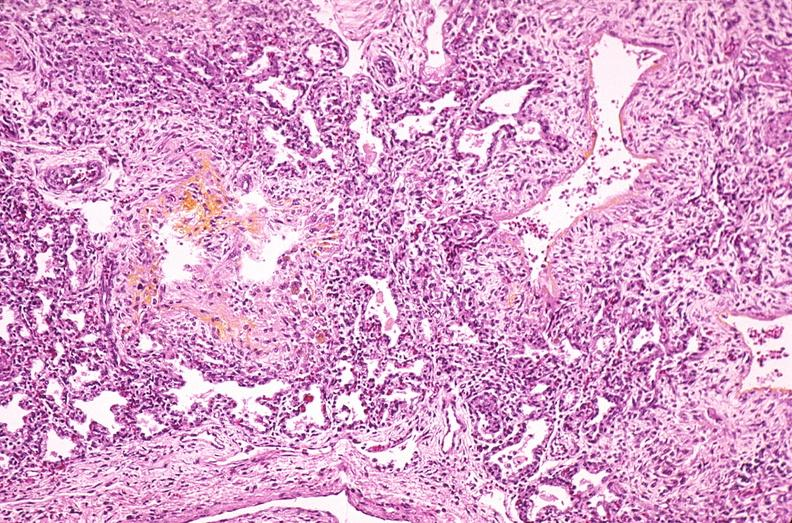why does this image show lung, hyaline membrane disease, yellow discoloration?
Answer the question using a single word or phrase. Due to hyperbilirubinemia 